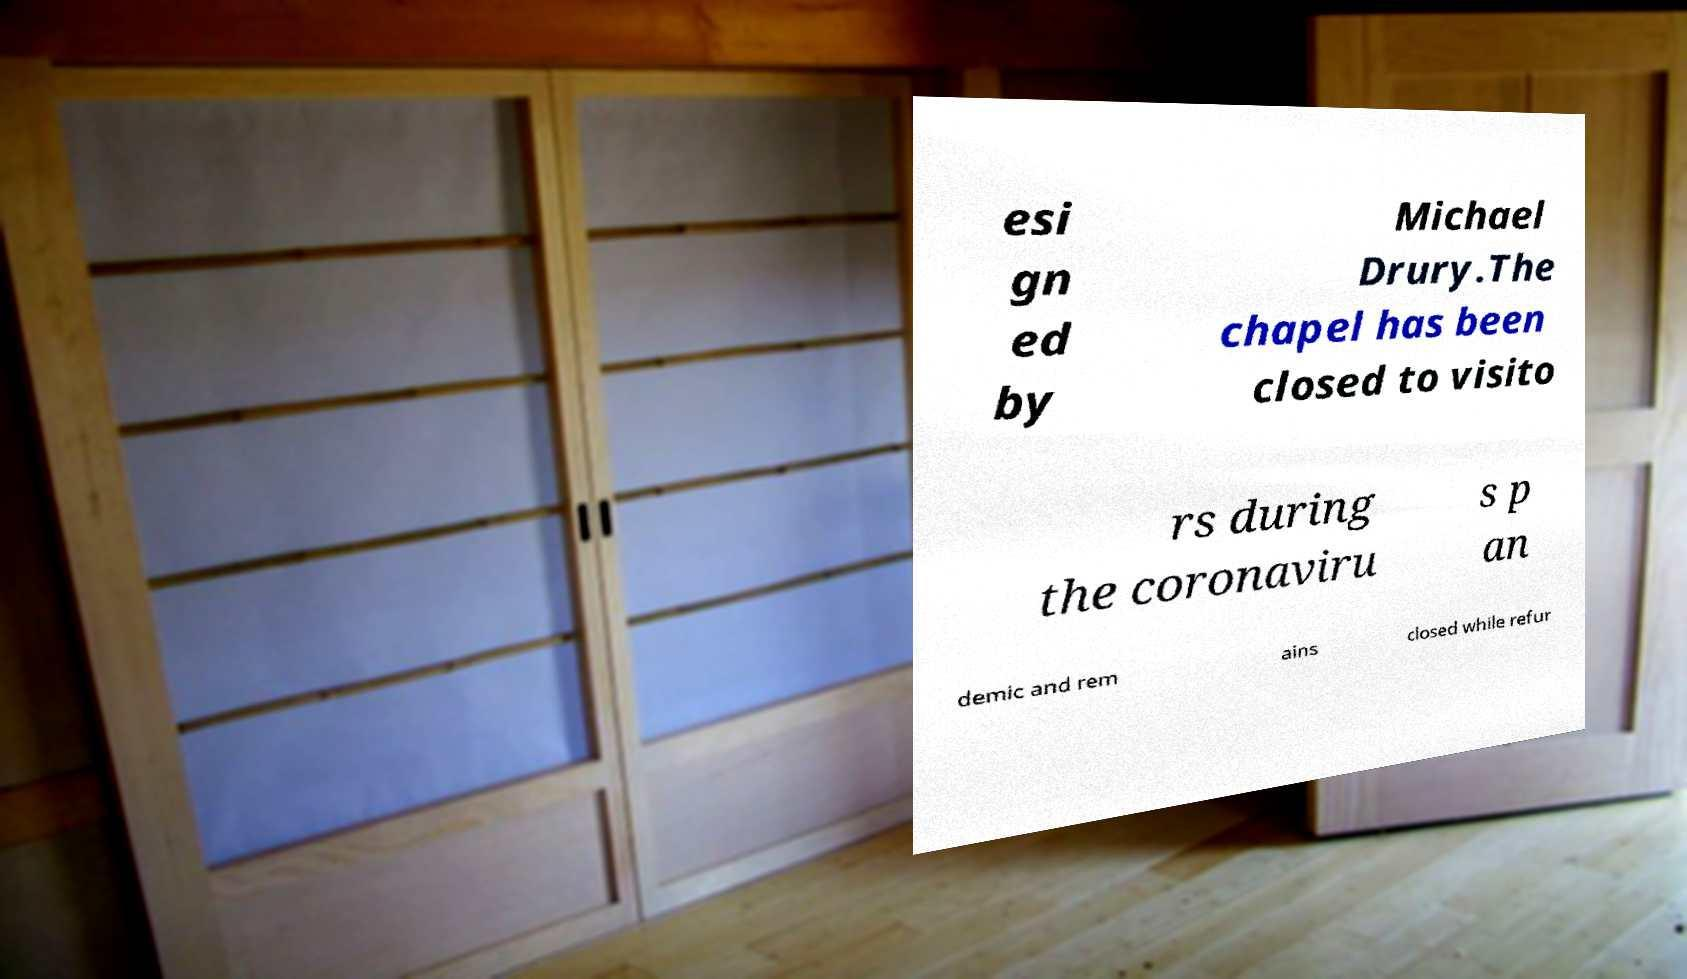I need the written content from this picture converted into text. Can you do that? esi gn ed by Michael Drury.The chapel has been closed to visito rs during the coronaviru s p an demic and rem ains closed while refur 